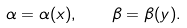<formula> <loc_0><loc_0><loc_500><loc_500>\alpha = \alpha ( x ) , \quad \beta = \beta ( y ) .</formula> 